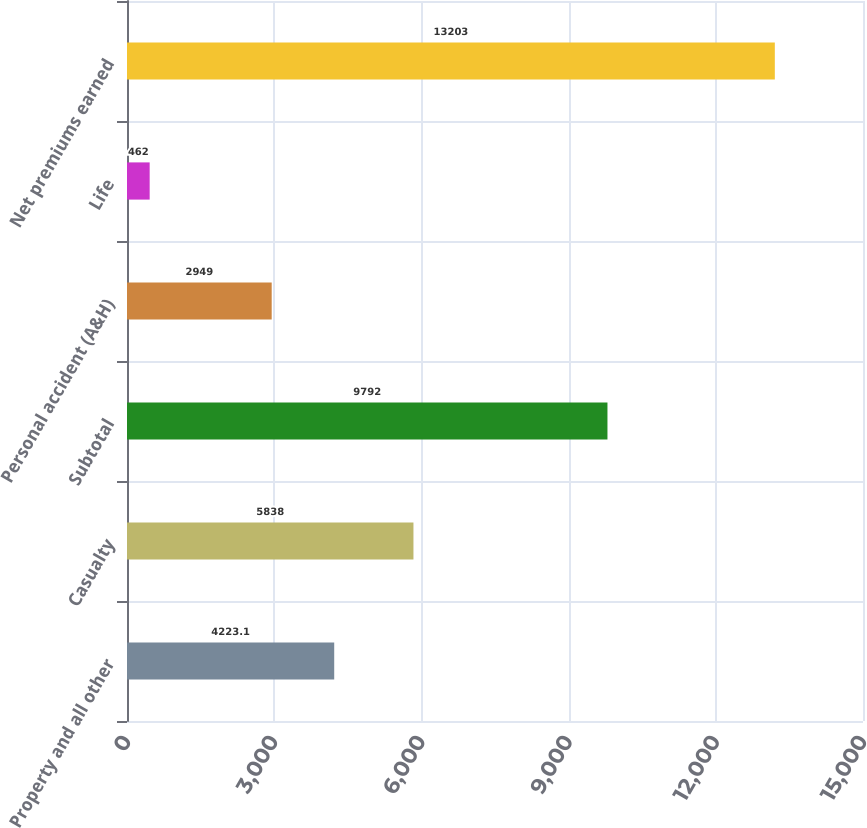Convert chart. <chart><loc_0><loc_0><loc_500><loc_500><bar_chart><fcel>Property and all other<fcel>Casualty<fcel>Subtotal<fcel>Personal accident (A&H)<fcel>Life<fcel>Net premiums earned<nl><fcel>4223.1<fcel>5838<fcel>9792<fcel>2949<fcel>462<fcel>13203<nl></chart> 